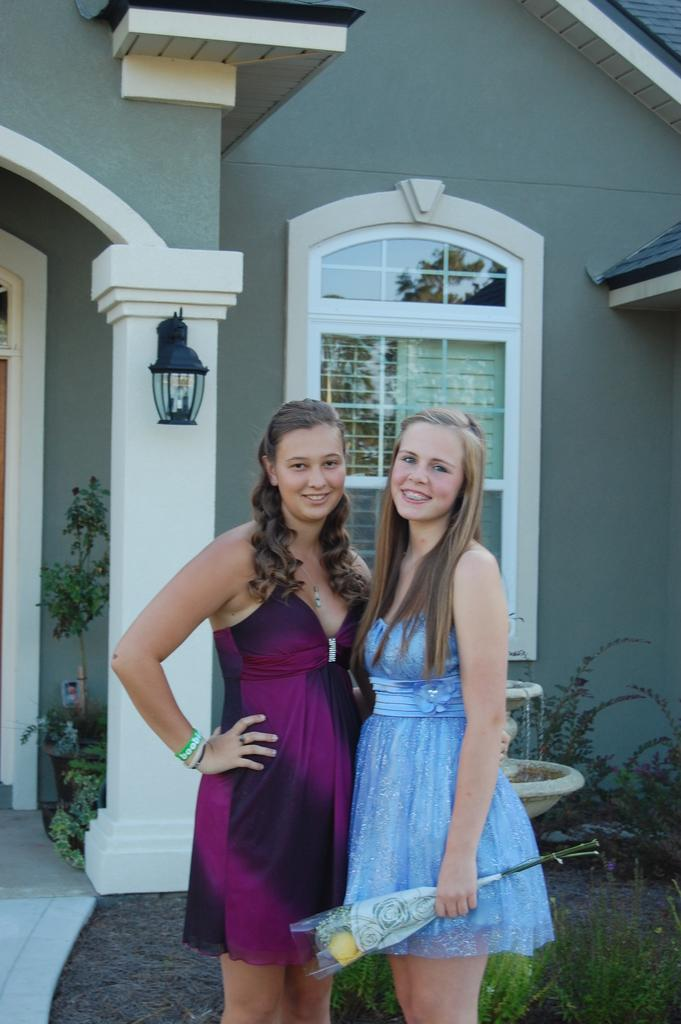How many women are in the image? There are two women in the image. What are the women wearing? The women are wearing frocks. What is one of the women holding? One woman is holding a bouquet. What can be seen in the background of the image? There is a building, a lamp, and plants in the background of the image. How many brothers are visible in the image? There are no brothers present in the image; it features two women. What type of beam is supporting the building in the image? There is no beam visible in the image; only the building itself is shown. 